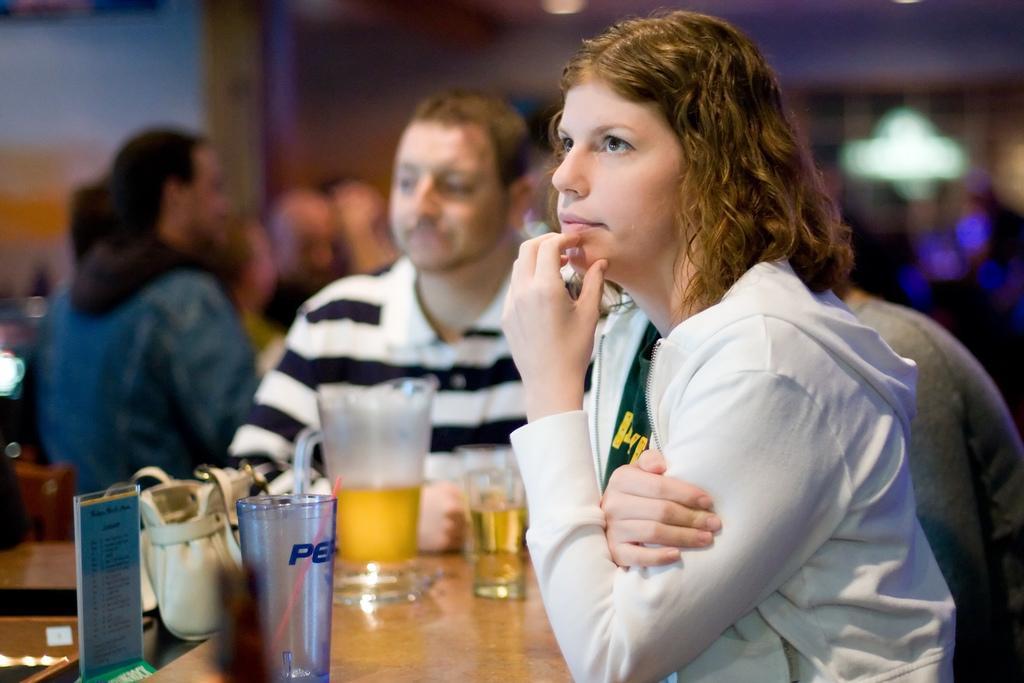In one or two sentences, can you explain what this image depicts? Here I can see three people are sitting facing towards the left side. In front of these people there is a table on which a jar, glasses, a bag and some other objects are placed. In the background, I can see some other people. At the top of the image there is a wall. The background is blurred. 